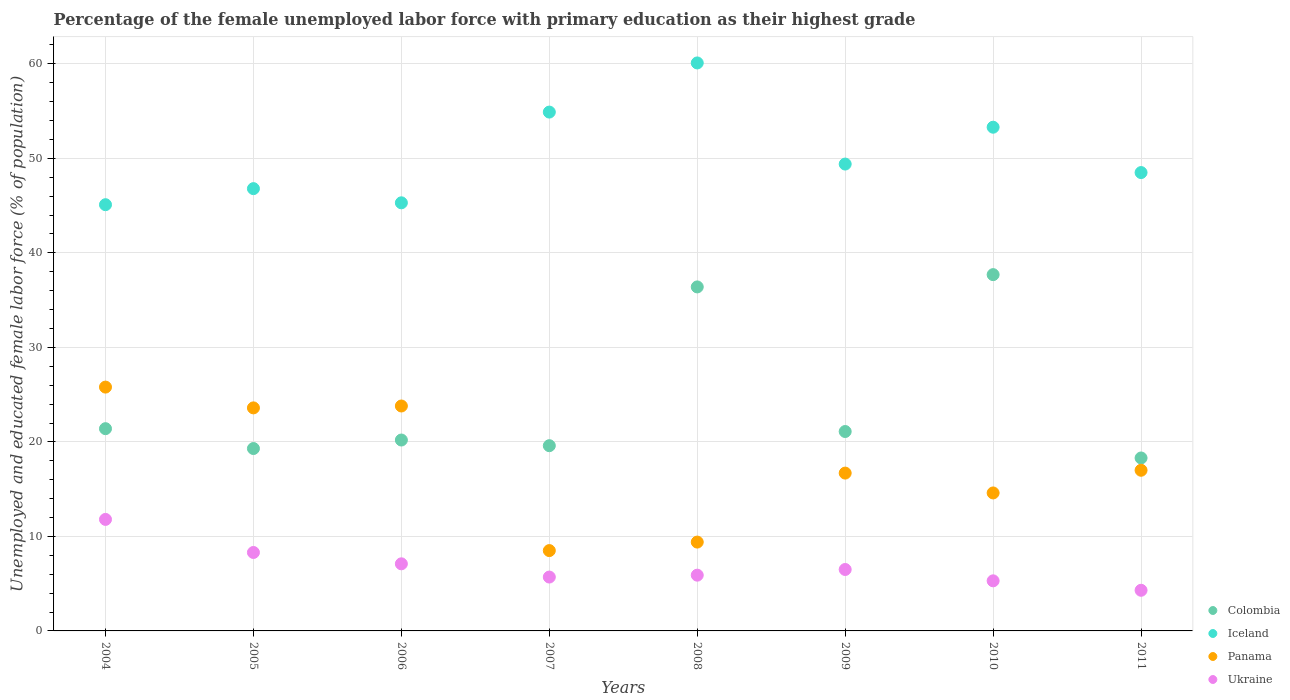How many different coloured dotlines are there?
Give a very brief answer. 4. Is the number of dotlines equal to the number of legend labels?
Provide a succinct answer. Yes. What is the percentage of the unemployed female labor force with primary education in Iceland in 2004?
Offer a very short reply. 45.1. Across all years, what is the maximum percentage of the unemployed female labor force with primary education in Iceland?
Offer a very short reply. 60.1. Across all years, what is the minimum percentage of the unemployed female labor force with primary education in Iceland?
Provide a short and direct response. 45.1. In which year was the percentage of the unemployed female labor force with primary education in Panama maximum?
Provide a succinct answer. 2004. What is the total percentage of the unemployed female labor force with primary education in Iceland in the graph?
Provide a short and direct response. 403.4. What is the difference between the percentage of the unemployed female labor force with primary education in Ukraine in 2004 and that in 2006?
Provide a short and direct response. 4.7. What is the difference between the percentage of the unemployed female labor force with primary education in Iceland in 2007 and the percentage of the unemployed female labor force with primary education in Panama in 2008?
Provide a short and direct response. 45.5. What is the average percentage of the unemployed female labor force with primary education in Ukraine per year?
Your answer should be very brief. 6.86. In the year 2009, what is the difference between the percentage of the unemployed female labor force with primary education in Colombia and percentage of the unemployed female labor force with primary education in Iceland?
Ensure brevity in your answer.  -28.3. In how many years, is the percentage of the unemployed female labor force with primary education in Iceland greater than 4 %?
Your response must be concise. 8. What is the ratio of the percentage of the unemployed female labor force with primary education in Colombia in 2010 to that in 2011?
Offer a very short reply. 2.06. Is the percentage of the unemployed female labor force with primary education in Colombia in 2004 less than that in 2010?
Your answer should be very brief. Yes. Is the difference between the percentage of the unemployed female labor force with primary education in Colombia in 2007 and 2009 greater than the difference between the percentage of the unemployed female labor force with primary education in Iceland in 2007 and 2009?
Your answer should be very brief. No. What is the difference between the highest and the second highest percentage of the unemployed female labor force with primary education in Iceland?
Your answer should be compact. 5.2. What is the difference between the highest and the lowest percentage of the unemployed female labor force with primary education in Colombia?
Ensure brevity in your answer.  19.4. In how many years, is the percentage of the unemployed female labor force with primary education in Colombia greater than the average percentage of the unemployed female labor force with primary education in Colombia taken over all years?
Ensure brevity in your answer.  2. Is the sum of the percentage of the unemployed female labor force with primary education in Ukraine in 2006 and 2007 greater than the maximum percentage of the unemployed female labor force with primary education in Colombia across all years?
Your answer should be very brief. No. Is the percentage of the unemployed female labor force with primary education in Colombia strictly less than the percentage of the unemployed female labor force with primary education in Panama over the years?
Keep it short and to the point. No. What is the difference between two consecutive major ticks on the Y-axis?
Offer a very short reply. 10. Are the values on the major ticks of Y-axis written in scientific E-notation?
Provide a succinct answer. No. Does the graph contain any zero values?
Make the answer very short. No. How many legend labels are there?
Ensure brevity in your answer.  4. What is the title of the graph?
Offer a terse response. Percentage of the female unemployed labor force with primary education as their highest grade. What is the label or title of the Y-axis?
Provide a short and direct response. Unemployed and educated female labor force (% of population). What is the Unemployed and educated female labor force (% of population) in Colombia in 2004?
Keep it short and to the point. 21.4. What is the Unemployed and educated female labor force (% of population) of Iceland in 2004?
Your response must be concise. 45.1. What is the Unemployed and educated female labor force (% of population) of Panama in 2004?
Ensure brevity in your answer.  25.8. What is the Unemployed and educated female labor force (% of population) of Ukraine in 2004?
Your answer should be compact. 11.8. What is the Unemployed and educated female labor force (% of population) of Colombia in 2005?
Provide a short and direct response. 19.3. What is the Unemployed and educated female labor force (% of population) in Iceland in 2005?
Offer a very short reply. 46.8. What is the Unemployed and educated female labor force (% of population) of Panama in 2005?
Give a very brief answer. 23.6. What is the Unemployed and educated female labor force (% of population) of Ukraine in 2005?
Keep it short and to the point. 8.3. What is the Unemployed and educated female labor force (% of population) in Colombia in 2006?
Give a very brief answer. 20.2. What is the Unemployed and educated female labor force (% of population) of Iceland in 2006?
Your response must be concise. 45.3. What is the Unemployed and educated female labor force (% of population) of Panama in 2006?
Make the answer very short. 23.8. What is the Unemployed and educated female labor force (% of population) of Ukraine in 2006?
Provide a short and direct response. 7.1. What is the Unemployed and educated female labor force (% of population) of Colombia in 2007?
Ensure brevity in your answer.  19.6. What is the Unemployed and educated female labor force (% of population) in Iceland in 2007?
Provide a succinct answer. 54.9. What is the Unemployed and educated female labor force (% of population) of Ukraine in 2007?
Provide a short and direct response. 5.7. What is the Unemployed and educated female labor force (% of population) in Colombia in 2008?
Ensure brevity in your answer.  36.4. What is the Unemployed and educated female labor force (% of population) of Iceland in 2008?
Offer a very short reply. 60.1. What is the Unemployed and educated female labor force (% of population) in Panama in 2008?
Offer a terse response. 9.4. What is the Unemployed and educated female labor force (% of population) in Ukraine in 2008?
Provide a succinct answer. 5.9. What is the Unemployed and educated female labor force (% of population) of Colombia in 2009?
Ensure brevity in your answer.  21.1. What is the Unemployed and educated female labor force (% of population) of Iceland in 2009?
Your answer should be compact. 49.4. What is the Unemployed and educated female labor force (% of population) in Panama in 2009?
Make the answer very short. 16.7. What is the Unemployed and educated female labor force (% of population) of Colombia in 2010?
Your answer should be very brief. 37.7. What is the Unemployed and educated female labor force (% of population) in Iceland in 2010?
Make the answer very short. 53.3. What is the Unemployed and educated female labor force (% of population) in Panama in 2010?
Your response must be concise. 14.6. What is the Unemployed and educated female labor force (% of population) in Ukraine in 2010?
Provide a short and direct response. 5.3. What is the Unemployed and educated female labor force (% of population) in Colombia in 2011?
Keep it short and to the point. 18.3. What is the Unemployed and educated female labor force (% of population) in Iceland in 2011?
Offer a terse response. 48.5. What is the Unemployed and educated female labor force (% of population) in Ukraine in 2011?
Provide a succinct answer. 4.3. Across all years, what is the maximum Unemployed and educated female labor force (% of population) in Colombia?
Your response must be concise. 37.7. Across all years, what is the maximum Unemployed and educated female labor force (% of population) of Iceland?
Give a very brief answer. 60.1. Across all years, what is the maximum Unemployed and educated female labor force (% of population) in Panama?
Give a very brief answer. 25.8. Across all years, what is the maximum Unemployed and educated female labor force (% of population) of Ukraine?
Your answer should be compact. 11.8. Across all years, what is the minimum Unemployed and educated female labor force (% of population) of Colombia?
Provide a succinct answer. 18.3. Across all years, what is the minimum Unemployed and educated female labor force (% of population) in Iceland?
Keep it short and to the point. 45.1. Across all years, what is the minimum Unemployed and educated female labor force (% of population) of Panama?
Make the answer very short. 8.5. Across all years, what is the minimum Unemployed and educated female labor force (% of population) of Ukraine?
Make the answer very short. 4.3. What is the total Unemployed and educated female labor force (% of population) of Colombia in the graph?
Your answer should be compact. 194. What is the total Unemployed and educated female labor force (% of population) in Iceland in the graph?
Your answer should be very brief. 403.4. What is the total Unemployed and educated female labor force (% of population) of Panama in the graph?
Your answer should be compact. 139.4. What is the total Unemployed and educated female labor force (% of population) in Ukraine in the graph?
Give a very brief answer. 54.9. What is the difference between the Unemployed and educated female labor force (% of population) of Colombia in 2004 and that in 2005?
Ensure brevity in your answer.  2.1. What is the difference between the Unemployed and educated female labor force (% of population) in Iceland in 2004 and that in 2005?
Provide a short and direct response. -1.7. What is the difference between the Unemployed and educated female labor force (% of population) of Ukraine in 2004 and that in 2005?
Make the answer very short. 3.5. What is the difference between the Unemployed and educated female labor force (% of population) in Colombia in 2004 and that in 2006?
Your answer should be very brief. 1.2. What is the difference between the Unemployed and educated female labor force (% of population) of Iceland in 2004 and that in 2006?
Give a very brief answer. -0.2. What is the difference between the Unemployed and educated female labor force (% of population) of Ukraine in 2004 and that in 2006?
Keep it short and to the point. 4.7. What is the difference between the Unemployed and educated female labor force (% of population) of Panama in 2004 and that in 2007?
Ensure brevity in your answer.  17.3. What is the difference between the Unemployed and educated female labor force (% of population) in Iceland in 2004 and that in 2008?
Offer a terse response. -15. What is the difference between the Unemployed and educated female labor force (% of population) in Panama in 2004 and that in 2008?
Make the answer very short. 16.4. What is the difference between the Unemployed and educated female labor force (% of population) of Colombia in 2004 and that in 2009?
Make the answer very short. 0.3. What is the difference between the Unemployed and educated female labor force (% of population) in Iceland in 2004 and that in 2009?
Your answer should be very brief. -4.3. What is the difference between the Unemployed and educated female labor force (% of population) of Panama in 2004 and that in 2009?
Your response must be concise. 9.1. What is the difference between the Unemployed and educated female labor force (% of population) of Colombia in 2004 and that in 2010?
Offer a terse response. -16.3. What is the difference between the Unemployed and educated female labor force (% of population) in Iceland in 2004 and that in 2010?
Your response must be concise. -8.2. What is the difference between the Unemployed and educated female labor force (% of population) of Iceland in 2004 and that in 2011?
Offer a terse response. -3.4. What is the difference between the Unemployed and educated female labor force (% of population) of Colombia in 2005 and that in 2006?
Your answer should be very brief. -0.9. What is the difference between the Unemployed and educated female labor force (% of population) of Iceland in 2005 and that in 2006?
Provide a succinct answer. 1.5. What is the difference between the Unemployed and educated female labor force (% of population) of Ukraine in 2005 and that in 2006?
Keep it short and to the point. 1.2. What is the difference between the Unemployed and educated female labor force (% of population) of Panama in 2005 and that in 2007?
Provide a succinct answer. 15.1. What is the difference between the Unemployed and educated female labor force (% of population) in Colombia in 2005 and that in 2008?
Your answer should be very brief. -17.1. What is the difference between the Unemployed and educated female labor force (% of population) of Iceland in 2005 and that in 2009?
Make the answer very short. -2.6. What is the difference between the Unemployed and educated female labor force (% of population) of Ukraine in 2005 and that in 2009?
Your response must be concise. 1.8. What is the difference between the Unemployed and educated female labor force (% of population) in Colombia in 2005 and that in 2010?
Ensure brevity in your answer.  -18.4. What is the difference between the Unemployed and educated female labor force (% of population) in Iceland in 2005 and that in 2010?
Give a very brief answer. -6.5. What is the difference between the Unemployed and educated female labor force (% of population) in Panama in 2005 and that in 2010?
Keep it short and to the point. 9. What is the difference between the Unemployed and educated female labor force (% of population) of Ukraine in 2005 and that in 2011?
Your response must be concise. 4. What is the difference between the Unemployed and educated female labor force (% of population) of Iceland in 2006 and that in 2007?
Your answer should be compact. -9.6. What is the difference between the Unemployed and educated female labor force (% of population) in Panama in 2006 and that in 2007?
Provide a short and direct response. 15.3. What is the difference between the Unemployed and educated female labor force (% of population) of Colombia in 2006 and that in 2008?
Offer a very short reply. -16.2. What is the difference between the Unemployed and educated female labor force (% of population) of Iceland in 2006 and that in 2008?
Provide a succinct answer. -14.8. What is the difference between the Unemployed and educated female labor force (% of population) in Panama in 2006 and that in 2008?
Offer a terse response. 14.4. What is the difference between the Unemployed and educated female labor force (% of population) in Colombia in 2006 and that in 2009?
Offer a terse response. -0.9. What is the difference between the Unemployed and educated female labor force (% of population) in Iceland in 2006 and that in 2009?
Your answer should be compact. -4.1. What is the difference between the Unemployed and educated female labor force (% of population) of Panama in 2006 and that in 2009?
Your answer should be compact. 7.1. What is the difference between the Unemployed and educated female labor force (% of population) of Ukraine in 2006 and that in 2009?
Provide a succinct answer. 0.6. What is the difference between the Unemployed and educated female labor force (% of population) in Colombia in 2006 and that in 2010?
Provide a succinct answer. -17.5. What is the difference between the Unemployed and educated female labor force (% of population) of Panama in 2006 and that in 2010?
Your answer should be very brief. 9.2. What is the difference between the Unemployed and educated female labor force (% of population) of Colombia in 2007 and that in 2008?
Your response must be concise. -16.8. What is the difference between the Unemployed and educated female labor force (% of population) in Iceland in 2007 and that in 2008?
Make the answer very short. -5.2. What is the difference between the Unemployed and educated female labor force (% of population) in Panama in 2007 and that in 2008?
Offer a terse response. -0.9. What is the difference between the Unemployed and educated female labor force (% of population) in Iceland in 2007 and that in 2009?
Your answer should be compact. 5.5. What is the difference between the Unemployed and educated female labor force (% of population) of Ukraine in 2007 and that in 2009?
Provide a short and direct response. -0.8. What is the difference between the Unemployed and educated female labor force (% of population) in Colombia in 2007 and that in 2010?
Ensure brevity in your answer.  -18.1. What is the difference between the Unemployed and educated female labor force (% of population) in Panama in 2007 and that in 2010?
Give a very brief answer. -6.1. What is the difference between the Unemployed and educated female labor force (% of population) of Colombia in 2008 and that in 2009?
Provide a short and direct response. 15.3. What is the difference between the Unemployed and educated female labor force (% of population) in Panama in 2008 and that in 2009?
Provide a short and direct response. -7.3. What is the difference between the Unemployed and educated female labor force (% of population) of Panama in 2008 and that in 2010?
Your answer should be compact. -5.2. What is the difference between the Unemployed and educated female labor force (% of population) in Colombia in 2009 and that in 2010?
Your answer should be compact. -16.6. What is the difference between the Unemployed and educated female labor force (% of population) in Colombia in 2009 and that in 2011?
Make the answer very short. 2.8. What is the difference between the Unemployed and educated female labor force (% of population) in Iceland in 2009 and that in 2011?
Your answer should be very brief. 0.9. What is the difference between the Unemployed and educated female labor force (% of population) of Iceland in 2010 and that in 2011?
Offer a terse response. 4.8. What is the difference between the Unemployed and educated female labor force (% of population) in Panama in 2010 and that in 2011?
Keep it short and to the point. -2.4. What is the difference between the Unemployed and educated female labor force (% of population) in Ukraine in 2010 and that in 2011?
Offer a very short reply. 1. What is the difference between the Unemployed and educated female labor force (% of population) in Colombia in 2004 and the Unemployed and educated female labor force (% of population) in Iceland in 2005?
Make the answer very short. -25.4. What is the difference between the Unemployed and educated female labor force (% of population) of Iceland in 2004 and the Unemployed and educated female labor force (% of population) of Panama in 2005?
Your response must be concise. 21.5. What is the difference between the Unemployed and educated female labor force (% of population) in Iceland in 2004 and the Unemployed and educated female labor force (% of population) in Ukraine in 2005?
Your response must be concise. 36.8. What is the difference between the Unemployed and educated female labor force (% of population) of Panama in 2004 and the Unemployed and educated female labor force (% of population) of Ukraine in 2005?
Offer a terse response. 17.5. What is the difference between the Unemployed and educated female labor force (% of population) in Colombia in 2004 and the Unemployed and educated female labor force (% of population) in Iceland in 2006?
Your answer should be compact. -23.9. What is the difference between the Unemployed and educated female labor force (% of population) of Colombia in 2004 and the Unemployed and educated female labor force (% of population) of Panama in 2006?
Your answer should be compact. -2.4. What is the difference between the Unemployed and educated female labor force (% of population) of Iceland in 2004 and the Unemployed and educated female labor force (% of population) of Panama in 2006?
Keep it short and to the point. 21.3. What is the difference between the Unemployed and educated female labor force (% of population) of Colombia in 2004 and the Unemployed and educated female labor force (% of population) of Iceland in 2007?
Give a very brief answer. -33.5. What is the difference between the Unemployed and educated female labor force (% of population) of Colombia in 2004 and the Unemployed and educated female labor force (% of population) of Panama in 2007?
Give a very brief answer. 12.9. What is the difference between the Unemployed and educated female labor force (% of population) in Iceland in 2004 and the Unemployed and educated female labor force (% of population) in Panama in 2007?
Provide a short and direct response. 36.6. What is the difference between the Unemployed and educated female labor force (% of population) of Iceland in 2004 and the Unemployed and educated female labor force (% of population) of Ukraine in 2007?
Your answer should be compact. 39.4. What is the difference between the Unemployed and educated female labor force (% of population) of Panama in 2004 and the Unemployed and educated female labor force (% of population) of Ukraine in 2007?
Keep it short and to the point. 20.1. What is the difference between the Unemployed and educated female labor force (% of population) of Colombia in 2004 and the Unemployed and educated female labor force (% of population) of Iceland in 2008?
Ensure brevity in your answer.  -38.7. What is the difference between the Unemployed and educated female labor force (% of population) of Iceland in 2004 and the Unemployed and educated female labor force (% of population) of Panama in 2008?
Your answer should be very brief. 35.7. What is the difference between the Unemployed and educated female labor force (% of population) of Iceland in 2004 and the Unemployed and educated female labor force (% of population) of Ukraine in 2008?
Provide a succinct answer. 39.2. What is the difference between the Unemployed and educated female labor force (% of population) in Panama in 2004 and the Unemployed and educated female labor force (% of population) in Ukraine in 2008?
Give a very brief answer. 19.9. What is the difference between the Unemployed and educated female labor force (% of population) of Colombia in 2004 and the Unemployed and educated female labor force (% of population) of Ukraine in 2009?
Your response must be concise. 14.9. What is the difference between the Unemployed and educated female labor force (% of population) of Iceland in 2004 and the Unemployed and educated female labor force (% of population) of Panama in 2009?
Offer a terse response. 28.4. What is the difference between the Unemployed and educated female labor force (% of population) of Iceland in 2004 and the Unemployed and educated female labor force (% of population) of Ukraine in 2009?
Your response must be concise. 38.6. What is the difference between the Unemployed and educated female labor force (% of population) of Panama in 2004 and the Unemployed and educated female labor force (% of population) of Ukraine in 2009?
Provide a succinct answer. 19.3. What is the difference between the Unemployed and educated female labor force (% of population) in Colombia in 2004 and the Unemployed and educated female labor force (% of population) in Iceland in 2010?
Offer a very short reply. -31.9. What is the difference between the Unemployed and educated female labor force (% of population) in Colombia in 2004 and the Unemployed and educated female labor force (% of population) in Panama in 2010?
Ensure brevity in your answer.  6.8. What is the difference between the Unemployed and educated female labor force (% of population) of Colombia in 2004 and the Unemployed and educated female labor force (% of population) of Ukraine in 2010?
Provide a succinct answer. 16.1. What is the difference between the Unemployed and educated female labor force (% of population) of Iceland in 2004 and the Unemployed and educated female labor force (% of population) of Panama in 2010?
Keep it short and to the point. 30.5. What is the difference between the Unemployed and educated female labor force (% of population) in Iceland in 2004 and the Unemployed and educated female labor force (% of population) in Ukraine in 2010?
Offer a terse response. 39.8. What is the difference between the Unemployed and educated female labor force (% of population) in Colombia in 2004 and the Unemployed and educated female labor force (% of population) in Iceland in 2011?
Your answer should be very brief. -27.1. What is the difference between the Unemployed and educated female labor force (% of population) in Colombia in 2004 and the Unemployed and educated female labor force (% of population) in Panama in 2011?
Your answer should be very brief. 4.4. What is the difference between the Unemployed and educated female labor force (% of population) of Iceland in 2004 and the Unemployed and educated female labor force (% of population) of Panama in 2011?
Your answer should be compact. 28.1. What is the difference between the Unemployed and educated female labor force (% of population) in Iceland in 2004 and the Unemployed and educated female labor force (% of population) in Ukraine in 2011?
Your answer should be very brief. 40.8. What is the difference between the Unemployed and educated female labor force (% of population) of Colombia in 2005 and the Unemployed and educated female labor force (% of population) of Panama in 2006?
Your response must be concise. -4.5. What is the difference between the Unemployed and educated female labor force (% of population) of Iceland in 2005 and the Unemployed and educated female labor force (% of population) of Panama in 2006?
Provide a short and direct response. 23. What is the difference between the Unemployed and educated female labor force (% of population) in Iceland in 2005 and the Unemployed and educated female labor force (% of population) in Ukraine in 2006?
Your response must be concise. 39.7. What is the difference between the Unemployed and educated female labor force (% of population) of Panama in 2005 and the Unemployed and educated female labor force (% of population) of Ukraine in 2006?
Your answer should be compact. 16.5. What is the difference between the Unemployed and educated female labor force (% of population) in Colombia in 2005 and the Unemployed and educated female labor force (% of population) in Iceland in 2007?
Keep it short and to the point. -35.6. What is the difference between the Unemployed and educated female labor force (% of population) in Colombia in 2005 and the Unemployed and educated female labor force (% of population) in Panama in 2007?
Provide a short and direct response. 10.8. What is the difference between the Unemployed and educated female labor force (% of population) of Iceland in 2005 and the Unemployed and educated female labor force (% of population) of Panama in 2007?
Your answer should be very brief. 38.3. What is the difference between the Unemployed and educated female labor force (% of population) of Iceland in 2005 and the Unemployed and educated female labor force (% of population) of Ukraine in 2007?
Give a very brief answer. 41.1. What is the difference between the Unemployed and educated female labor force (% of population) in Panama in 2005 and the Unemployed and educated female labor force (% of population) in Ukraine in 2007?
Your response must be concise. 17.9. What is the difference between the Unemployed and educated female labor force (% of population) of Colombia in 2005 and the Unemployed and educated female labor force (% of population) of Iceland in 2008?
Offer a terse response. -40.8. What is the difference between the Unemployed and educated female labor force (% of population) of Colombia in 2005 and the Unemployed and educated female labor force (% of population) of Panama in 2008?
Ensure brevity in your answer.  9.9. What is the difference between the Unemployed and educated female labor force (% of population) of Colombia in 2005 and the Unemployed and educated female labor force (% of population) of Ukraine in 2008?
Provide a succinct answer. 13.4. What is the difference between the Unemployed and educated female labor force (% of population) in Iceland in 2005 and the Unemployed and educated female labor force (% of population) in Panama in 2008?
Provide a succinct answer. 37.4. What is the difference between the Unemployed and educated female labor force (% of population) in Iceland in 2005 and the Unemployed and educated female labor force (% of population) in Ukraine in 2008?
Offer a very short reply. 40.9. What is the difference between the Unemployed and educated female labor force (% of population) in Panama in 2005 and the Unemployed and educated female labor force (% of population) in Ukraine in 2008?
Offer a terse response. 17.7. What is the difference between the Unemployed and educated female labor force (% of population) in Colombia in 2005 and the Unemployed and educated female labor force (% of population) in Iceland in 2009?
Ensure brevity in your answer.  -30.1. What is the difference between the Unemployed and educated female labor force (% of population) in Colombia in 2005 and the Unemployed and educated female labor force (% of population) in Ukraine in 2009?
Give a very brief answer. 12.8. What is the difference between the Unemployed and educated female labor force (% of population) in Iceland in 2005 and the Unemployed and educated female labor force (% of population) in Panama in 2009?
Offer a very short reply. 30.1. What is the difference between the Unemployed and educated female labor force (% of population) in Iceland in 2005 and the Unemployed and educated female labor force (% of population) in Ukraine in 2009?
Your response must be concise. 40.3. What is the difference between the Unemployed and educated female labor force (% of population) of Colombia in 2005 and the Unemployed and educated female labor force (% of population) of Iceland in 2010?
Make the answer very short. -34. What is the difference between the Unemployed and educated female labor force (% of population) of Colombia in 2005 and the Unemployed and educated female labor force (% of population) of Ukraine in 2010?
Your answer should be compact. 14. What is the difference between the Unemployed and educated female labor force (% of population) of Iceland in 2005 and the Unemployed and educated female labor force (% of population) of Panama in 2010?
Keep it short and to the point. 32.2. What is the difference between the Unemployed and educated female labor force (% of population) in Iceland in 2005 and the Unemployed and educated female labor force (% of population) in Ukraine in 2010?
Offer a terse response. 41.5. What is the difference between the Unemployed and educated female labor force (% of population) of Colombia in 2005 and the Unemployed and educated female labor force (% of population) of Iceland in 2011?
Make the answer very short. -29.2. What is the difference between the Unemployed and educated female labor force (% of population) of Colombia in 2005 and the Unemployed and educated female labor force (% of population) of Ukraine in 2011?
Make the answer very short. 15. What is the difference between the Unemployed and educated female labor force (% of population) of Iceland in 2005 and the Unemployed and educated female labor force (% of population) of Panama in 2011?
Give a very brief answer. 29.8. What is the difference between the Unemployed and educated female labor force (% of population) of Iceland in 2005 and the Unemployed and educated female labor force (% of population) of Ukraine in 2011?
Offer a very short reply. 42.5. What is the difference between the Unemployed and educated female labor force (% of population) in Panama in 2005 and the Unemployed and educated female labor force (% of population) in Ukraine in 2011?
Offer a terse response. 19.3. What is the difference between the Unemployed and educated female labor force (% of population) of Colombia in 2006 and the Unemployed and educated female labor force (% of population) of Iceland in 2007?
Your answer should be compact. -34.7. What is the difference between the Unemployed and educated female labor force (% of population) of Colombia in 2006 and the Unemployed and educated female labor force (% of population) of Ukraine in 2007?
Make the answer very short. 14.5. What is the difference between the Unemployed and educated female labor force (% of population) in Iceland in 2006 and the Unemployed and educated female labor force (% of population) in Panama in 2007?
Your answer should be compact. 36.8. What is the difference between the Unemployed and educated female labor force (% of population) in Iceland in 2006 and the Unemployed and educated female labor force (% of population) in Ukraine in 2007?
Give a very brief answer. 39.6. What is the difference between the Unemployed and educated female labor force (% of population) of Colombia in 2006 and the Unemployed and educated female labor force (% of population) of Iceland in 2008?
Provide a succinct answer. -39.9. What is the difference between the Unemployed and educated female labor force (% of population) of Colombia in 2006 and the Unemployed and educated female labor force (% of population) of Ukraine in 2008?
Your answer should be compact. 14.3. What is the difference between the Unemployed and educated female labor force (% of population) in Iceland in 2006 and the Unemployed and educated female labor force (% of population) in Panama in 2008?
Offer a very short reply. 35.9. What is the difference between the Unemployed and educated female labor force (% of population) in Iceland in 2006 and the Unemployed and educated female labor force (% of population) in Ukraine in 2008?
Provide a short and direct response. 39.4. What is the difference between the Unemployed and educated female labor force (% of population) of Panama in 2006 and the Unemployed and educated female labor force (% of population) of Ukraine in 2008?
Provide a short and direct response. 17.9. What is the difference between the Unemployed and educated female labor force (% of population) in Colombia in 2006 and the Unemployed and educated female labor force (% of population) in Iceland in 2009?
Offer a terse response. -29.2. What is the difference between the Unemployed and educated female labor force (% of population) in Colombia in 2006 and the Unemployed and educated female labor force (% of population) in Ukraine in 2009?
Your answer should be very brief. 13.7. What is the difference between the Unemployed and educated female labor force (% of population) of Iceland in 2006 and the Unemployed and educated female labor force (% of population) of Panama in 2009?
Offer a terse response. 28.6. What is the difference between the Unemployed and educated female labor force (% of population) in Iceland in 2006 and the Unemployed and educated female labor force (% of population) in Ukraine in 2009?
Provide a short and direct response. 38.8. What is the difference between the Unemployed and educated female labor force (% of population) in Colombia in 2006 and the Unemployed and educated female labor force (% of population) in Iceland in 2010?
Your answer should be very brief. -33.1. What is the difference between the Unemployed and educated female labor force (% of population) of Colombia in 2006 and the Unemployed and educated female labor force (% of population) of Panama in 2010?
Provide a short and direct response. 5.6. What is the difference between the Unemployed and educated female labor force (% of population) of Colombia in 2006 and the Unemployed and educated female labor force (% of population) of Ukraine in 2010?
Keep it short and to the point. 14.9. What is the difference between the Unemployed and educated female labor force (% of population) of Iceland in 2006 and the Unemployed and educated female labor force (% of population) of Panama in 2010?
Provide a succinct answer. 30.7. What is the difference between the Unemployed and educated female labor force (% of population) in Panama in 2006 and the Unemployed and educated female labor force (% of population) in Ukraine in 2010?
Offer a very short reply. 18.5. What is the difference between the Unemployed and educated female labor force (% of population) of Colombia in 2006 and the Unemployed and educated female labor force (% of population) of Iceland in 2011?
Make the answer very short. -28.3. What is the difference between the Unemployed and educated female labor force (% of population) in Colombia in 2006 and the Unemployed and educated female labor force (% of population) in Panama in 2011?
Ensure brevity in your answer.  3.2. What is the difference between the Unemployed and educated female labor force (% of population) of Colombia in 2006 and the Unemployed and educated female labor force (% of population) of Ukraine in 2011?
Your response must be concise. 15.9. What is the difference between the Unemployed and educated female labor force (% of population) in Iceland in 2006 and the Unemployed and educated female labor force (% of population) in Panama in 2011?
Offer a very short reply. 28.3. What is the difference between the Unemployed and educated female labor force (% of population) of Iceland in 2006 and the Unemployed and educated female labor force (% of population) of Ukraine in 2011?
Provide a short and direct response. 41. What is the difference between the Unemployed and educated female labor force (% of population) of Colombia in 2007 and the Unemployed and educated female labor force (% of population) of Iceland in 2008?
Provide a short and direct response. -40.5. What is the difference between the Unemployed and educated female labor force (% of population) of Iceland in 2007 and the Unemployed and educated female labor force (% of population) of Panama in 2008?
Offer a very short reply. 45.5. What is the difference between the Unemployed and educated female labor force (% of population) in Iceland in 2007 and the Unemployed and educated female labor force (% of population) in Ukraine in 2008?
Provide a succinct answer. 49. What is the difference between the Unemployed and educated female labor force (% of population) of Panama in 2007 and the Unemployed and educated female labor force (% of population) of Ukraine in 2008?
Provide a short and direct response. 2.6. What is the difference between the Unemployed and educated female labor force (% of population) in Colombia in 2007 and the Unemployed and educated female labor force (% of population) in Iceland in 2009?
Offer a very short reply. -29.8. What is the difference between the Unemployed and educated female labor force (% of population) of Colombia in 2007 and the Unemployed and educated female labor force (% of population) of Panama in 2009?
Provide a succinct answer. 2.9. What is the difference between the Unemployed and educated female labor force (% of population) in Iceland in 2007 and the Unemployed and educated female labor force (% of population) in Panama in 2009?
Provide a short and direct response. 38.2. What is the difference between the Unemployed and educated female labor force (% of population) of Iceland in 2007 and the Unemployed and educated female labor force (% of population) of Ukraine in 2009?
Your answer should be very brief. 48.4. What is the difference between the Unemployed and educated female labor force (% of population) in Colombia in 2007 and the Unemployed and educated female labor force (% of population) in Iceland in 2010?
Offer a very short reply. -33.7. What is the difference between the Unemployed and educated female labor force (% of population) in Colombia in 2007 and the Unemployed and educated female labor force (% of population) in Panama in 2010?
Keep it short and to the point. 5. What is the difference between the Unemployed and educated female labor force (% of population) in Iceland in 2007 and the Unemployed and educated female labor force (% of population) in Panama in 2010?
Provide a short and direct response. 40.3. What is the difference between the Unemployed and educated female labor force (% of population) in Iceland in 2007 and the Unemployed and educated female labor force (% of population) in Ukraine in 2010?
Your answer should be very brief. 49.6. What is the difference between the Unemployed and educated female labor force (% of population) of Panama in 2007 and the Unemployed and educated female labor force (% of population) of Ukraine in 2010?
Your answer should be compact. 3.2. What is the difference between the Unemployed and educated female labor force (% of population) of Colombia in 2007 and the Unemployed and educated female labor force (% of population) of Iceland in 2011?
Provide a short and direct response. -28.9. What is the difference between the Unemployed and educated female labor force (% of population) in Colombia in 2007 and the Unemployed and educated female labor force (% of population) in Panama in 2011?
Provide a short and direct response. 2.6. What is the difference between the Unemployed and educated female labor force (% of population) of Iceland in 2007 and the Unemployed and educated female labor force (% of population) of Panama in 2011?
Keep it short and to the point. 37.9. What is the difference between the Unemployed and educated female labor force (% of population) in Iceland in 2007 and the Unemployed and educated female labor force (% of population) in Ukraine in 2011?
Make the answer very short. 50.6. What is the difference between the Unemployed and educated female labor force (% of population) of Panama in 2007 and the Unemployed and educated female labor force (% of population) of Ukraine in 2011?
Offer a very short reply. 4.2. What is the difference between the Unemployed and educated female labor force (% of population) of Colombia in 2008 and the Unemployed and educated female labor force (% of population) of Iceland in 2009?
Your answer should be very brief. -13. What is the difference between the Unemployed and educated female labor force (% of population) in Colombia in 2008 and the Unemployed and educated female labor force (% of population) in Ukraine in 2009?
Offer a very short reply. 29.9. What is the difference between the Unemployed and educated female labor force (% of population) of Iceland in 2008 and the Unemployed and educated female labor force (% of population) of Panama in 2009?
Offer a very short reply. 43.4. What is the difference between the Unemployed and educated female labor force (% of population) in Iceland in 2008 and the Unemployed and educated female labor force (% of population) in Ukraine in 2009?
Provide a short and direct response. 53.6. What is the difference between the Unemployed and educated female labor force (% of population) of Panama in 2008 and the Unemployed and educated female labor force (% of population) of Ukraine in 2009?
Make the answer very short. 2.9. What is the difference between the Unemployed and educated female labor force (% of population) of Colombia in 2008 and the Unemployed and educated female labor force (% of population) of Iceland in 2010?
Offer a terse response. -16.9. What is the difference between the Unemployed and educated female labor force (% of population) of Colombia in 2008 and the Unemployed and educated female labor force (% of population) of Panama in 2010?
Your response must be concise. 21.8. What is the difference between the Unemployed and educated female labor force (% of population) in Colombia in 2008 and the Unemployed and educated female labor force (% of population) in Ukraine in 2010?
Offer a very short reply. 31.1. What is the difference between the Unemployed and educated female labor force (% of population) of Iceland in 2008 and the Unemployed and educated female labor force (% of population) of Panama in 2010?
Your answer should be compact. 45.5. What is the difference between the Unemployed and educated female labor force (% of population) in Iceland in 2008 and the Unemployed and educated female labor force (% of population) in Ukraine in 2010?
Your answer should be compact. 54.8. What is the difference between the Unemployed and educated female labor force (% of population) of Colombia in 2008 and the Unemployed and educated female labor force (% of population) of Iceland in 2011?
Provide a succinct answer. -12.1. What is the difference between the Unemployed and educated female labor force (% of population) in Colombia in 2008 and the Unemployed and educated female labor force (% of population) in Panama in 2011?
Offer a terse response. 19.4. What is the difference between the Unemployed and educated female labor force (% of population) of Colombia in 2008 and the Unemployed and educated female labor force (% of population) of Ukraine in 2011?
Provide a short and direct response. 32.1. What is the difference between the Unemployed and educated female labor force (% of population) of Iceland in 2008 and the Unemployed and educated female labor force (% of population) of Panama in 2011?
Provide a succinct answer. 43.1. What is the difference between the Unemployed and educated female labor force (% of population) in Iceland in 2008 and the Unemployed and educated female labor force (% of population) in Ukraine in 2011?
Your answer should be very brief. 55.8. What is the difference between the Unemployed and educated female labor force (% of population) in Colombia in 2009 and the Unemployed and educated female labor force (% of population) in Iceland in 2010?
Ensure brevity in your answer.  -32.2. What is the difference between the Unemployed and educated female labor force (% of population) in Colombia in 2009 and the Unemployed and educated female labor force (% of population) in Ukraine in 2010?
Provide a short and direct response. 15.8. What is the difference between the Unemployed and educated female labor force (% of population) of Iceland in 2009 and the Unemployed and educated female labor force (% of population) of Panama in 2010?
Give a very brief answer. 34.8. What is the difference between the Unemployed and educated female labor force (% of population) in Iceland in 2009 and the Unemployed and educated female labor force (% of population) in Ukraine in 2010?
Offer a very short reply. 44.1. What is the difference between the Unemployed and educated female labor force (% of population) in Colombia in 2009 and the Unemployed and educated female labor force (% of population) in Iceland in 2011?
Offer a terse response. -27.4. What is the difference between the Unemployed and educated female labor force (% of population) in Iceland in 2009 and the Unemployed and educated female labor force (% of population) in Panama in 2011?
Ensure brevity in your answer.  32.4. What is the difference between the Unemployed and educated female labor force (% of population) of Iceland in 2009 and the Unemployed and educated female labor force (% of population) of Ukraine in 2011?
Ensure brevity in your answer.  45.1. What is the difference between the Unemployed and educated female labor force (% of population) in Colombia in 2010 and the Unemployed and educated female labor force (% of population) in Iceland in 2011?
Provide a succinct answer. -10.8. What is the difference between the Unemployed and educated female labor force (% of population) of Colombia in 2010 and the Unemployed and educated female labor force (% of population) of Panama in 2011?
Provide a short and direct response. 20.7. What is the difference between the Unemployed and educated female labor force (% of population) in Colombia in 2010 and the Unemployed and educated female labor force (% of population) in Ukraine in 2011?
Keep it short and to the point. 33.4. What is the difference between the Unemployed and educated female labor force (% of population) of Iceland in 2010 and the Unemployed and educated female labor force (% of population) of Panama in 2011?
Your response must be concise. 36.3. What is the average Unemployed and educated female labor force (% of population) in Colombia per year?
Make the answer very short. 24.25. What is the average Unemployed and educated female labor force (% of population) in Iceland per year?
Your response must be concise. 50.42. What is the average Unemployed and educated female labor force (% of population) in Panama per year?
Offer a very short reply. 17.43. What is the average Unemployed and educated female labor force (% of population) in Ukraine per year?
Make the answer very short. 6.86. In the year 2004, what is the difference between the Unemployed and educated female labor force (% of population) in Colombia and Unemployed and educated female labor force (% of population) in Iceland?
Your answer should be very brief. -23.7. In the year 2004, what is the difference between the Unemployed and educated female labor force (% of population) of Colombia and Unemployed and educated female labor force (% of population) of Ukraine?
Keep it short and to the point. 9.6. In the year 2004, what is the difference between the Unemployed and educated female labor force (% of population) of Iceland and Unemployed and educated female labor force (% of population) of Panama?
Your response must be concise. 19.3. In the year 2004, what is the difference between the Unemployed and educated female labor force (% of population) in Iceland and Unemployed and educated female labor force (% of population) in Ukraine?
Provide a succinct answer. 33.3. In the year 2005, what is the difference between the Unemployed and educated female labor force (% of population) of Colombia and Unemployed and educated female labor force (% of population) of Iceland?
Give a very brief answer. -27.5. In the year 2005, what is the difference between the Unemployed and educated female labor force (% of population) of Colombia and Unemployed and educated female labor force (% of population) of Panama?
Give a very brief answer. -4.3. In the year 2005, what is the difference between the Unemployed and educated female labor force (% of population) in Colombia and Unemployed and educated female labor force (% of population) in Ukraine?
Offer a very short reply. 11. In the year 2005, what is the difference between the Unemployed and educated female labor force (% of population) in Iceland and Unemployed and educated female labor force (% of population) in Panama?
Your answer should be very brief. 23.2. In the year 2005, what is the difference between the Unemployed and educated female labor force (% of population) in Iceland and Unemployed and educated female labor force (% of population) in Ukraine?
Keep it short and to the point. 38.5. In the year 2005, what is the difference between the Unemployed and educated female labor force (% of population) of Panama and Unemployed and educated female labor force (% of population) of Ukraine?
Ensure brevity in your answer.  15.3. In the year 2006, what is the difference between the Unemployed and educated female labor force (% of population) in Colombia and Unemployed and educated female labor force (% of population) in Iceland?
Keep it short and to the point. -25.1. In the year 2006, what is the difference between the Unemployed and educated female labor force (% of population) of Iceland and Unemployed and educated female labor force (% of population) of Panama?
Provide a succinct answer. 21.5. In the year 2006, what is the difference between the Unemployed and educated female labor force (% of population) in Iceland and Unemployed and educated female labor force (% of population) in Ukraine?
Offer a very short reply. 38.2. In the year 2006, what is the difference between the Unemployed and educated female labor force (% of population) of Panama and Unemployed and educated female labor force (% of population) of Ukraine?
Offer a terse response. 16.7. In the year 2007, what is the difference between the Unemployed and educated female labor force (% of population) in Colombia and Unemployed and educated female labor force (% of population) in Iceland?
Provide a short and direct response. -35.3. In the year 2007, what is the difference between the Unemployed and educated female labor force (% of population) of Iceland and Unemployed and educated female labor force (% of population) of Panama?
Your answer should be very brief. 46.4. In the year 2007, what is the difference between the Unemployed and educated female labor force (% of population) in Iceland and Unemployed and educated female labor force (% of population) in Ukraine?
Give a very brief answer. 49.2. In the year 2007, what is the difference between the Unemployed and educated female labor force (% of population) of Panama and Unemployed and educated female labor force (% of population) of Ukraine?
Give a very brief answer. 2.8. In the year 2008, what is the difference between the Unemployed and educated female labor force (% of population) of Colombia and Unemployed and educated female labor force (% of population) of Iceland?
Give a very brief answer. -23.7. In the year 2008, what is the difference between the Unemployed and educated female labor force (% of population) in Colombia and Unemployed and educated female labor force (% of population) in Panama?
Your answer should be compact. 27. In the year 2008, what is the difference between the Unemployed and educated female labor force (% of population) of Colombia and Unemployed and educated female labor force (% of population) of Ukraine?
Ensure brevity in your answer.  30.5. In the year 2008, what is the difference between the Unemployed and educated female labor force (% of population) in Iceland and Unemployed and educated female labor force (% of population) in Panama?
Your answer should be compact. 50.7. In the year 2008, what is the difference between the Unemployed and educated female labor force (% of population) of Iceland and Unemployed and educated female labor force (% of population) of Ukraine?
Your response must be concise. 54.2. In the year 2008, what is the difference between the Unemployed and educated female labor force (% of population) in Panama and Unemployed and educated female labor force (% of population) in Ukraine?
Provide a succinct answer. 3.5. In the year 2009, what is the difference between the Unemployed and educated female labor force (% of population) in Colombia and Unemployed and educated female labor force (% of population) in Iceland?
Offer a very short reply. -28.3. In the year 2009, what is the difference between the Unemployed and educated female labor force (% of population) in Colombia and Unemployed and educated female labor force (% of population) in Panama?
Ensure brevity in your answer.  4.4. In the year 2009, what is the difference between the Unemployed and educated female labor force (% of population) in Colombia and Unemployed and educated female labor force (% of population) in Ukraine?
Your response must be concise. 14.6. In the year 2009, what is the difference between the Unemployed and educated female labor force (% of population) in Iceland and Unemployed and educated female labor force (% of population) in Panama?
Your answer should be compact. 32.7. In the year 2009, what is the difference between the Unemployed and educated female labor force (% of population) in Iceland and Unemployed and educated female labor force (% of population) in Ukraine?
Your answer should be very brief. 42.9. In the year 2009, what is the difference between the Unemployed and educated female labor force (% of population) of Panama and Unemployed and educated female labor force (% of population) of Ukraine?
Give a very brief answer. 10.2. In the year 2010, what is the difference between the Unemployed and educated female labor force (% of population) of Colombia and Unemployed and educated female labor force (% of population) of Iceland?
Your answer should be compact. -15.6. In the year 2010, what is the difference between the Unemployed and educated female labor force (% of population) in Colombia and Unemployed and educated female labor force (% of population) in Panama?
Offer a very short reply. 23.1. In the year 2010, what is the difference between the Unemployed and educated female labor force (% of population) in Colombia and Unemployed and educated female labor force (% of population) in Ukraine?
Your response must be concise. 32.4. In the year 2010, what is the difference between the Unemployed and educated female labor force (% of population) of Iceland and Unemployed and educated female labor force (% of population) of Panama?
Offer a very short reply. 38.7. In the year 2010, what is the difference between the Unemployed and educated female labor force (% of population) of Iceland and Unemployed and educated female labor force (% of population) of Ukraine?
Keep it short and to the point. 48. In the year 2011, what is the difference between the Unemployed and educated female labor force (% of population) of Colombia and Unemployed and educated female labor force (% of population) of Iceland?
Your answer should be compact. -30.2. In the year 2011, what is the difference between the Unemployed and educated female labor force (% of population) of Colombia and Unemployed and educated female labor force (% of population) of Panama?
Provide a short and direct response. 1.3. In the year 2011, what is the difference between the Unemployed and educated female labor force (% of population) in Iceland and Unemployed and educated female labor force (% of population) in Panama?
Provide a succinct answer. 31.5. In the year 2011, what is the difference between the Unemployed and educated female labor force (% of population) of Iceland and Unemployed and educated female labor force (% of population) of Ukraine?
Ensure brevity in your answer.  44.2. In the year 2011, what is the difference between the Unemployed and educated female labor force (% of population) in Panama and Unemployed and educated female labor force (% of population) in Ukraine?
Ensure brevity in your answer.  12.7. What is the ratio of the Unemployed and educated female labor force (% of population) of Colombia in 2004 to that in 2005?
Give a very brief answer. 1.11. What is the ratio of the Unemployed and educated female labor force (% of population) of Iceland in 2004 to that in 2005?
Provide a short and direct response. 0.96. What is the ratio of the Unemployed and educated female labor force (% of population) of Panama in 2004 to that in 2005?
Make the answer very short. 1.09. What is the ratio of the Unemployed and educated female labor force (% of population) of Ukraine in 2004 to that in 2005?
Keep it short and to the point. 1.42. What is the ratio of the Unemployed and educated female labor force (% of population) in Colombia in 2004 to that in 2006?
Keep it short and to the point. 1.06. What is the ratio of the Unemployed and educated female labor force (% of population) of Iceland in 2004 to that in 2006?
Make the answer very short. 1. What is the ratio of the Unemployed and educated female labor force (% of population) in Panama in 2004 to that in 2006?
Your answer should be very brief. 1.08. What is the ratio of the Unemployed and educated female labor force (% of population) in Ukraine in 2004 to that in 2006?
Provide a succinct answer. 1.66. What is the ratio of the Unemployed and educated female labor force (% of population) in Colombia in 2004 to that in 2007?
Your answer should be very brief. 1.09. What is the ratio of the Unemployed and educated female labor force (% of population) in Iceland in 2004 to that in 2007?
Make the answer very short. 0.82. What is the ratio of the Unemployed and educated female labor force (% of population) of Panama in 2004 to that in 2007?
Offer a terse response. 3.04. What is the ratio of the Unemployed and educated female labor force (% of population) of Ukraine in 2004 to that in 2007?
Provide a succinct answer. 2.07. What is the ratio of the Unemployed and educated female labor force (% of population) of Colombia in 2004 to that in 2008?
Ensure brevity in your answer.  0.59. What is the ratio of the Unemployed and educated female labor force (% of population) of Iceland in 2004 to that in 2008?
Your response must be concise. 0.75. What is the ratio of the Unemployed and educated female labor force (% of population) of Panama in 2004 to that in 2008?
Your answer should be very brief. 2.74. What is the ratio of the Unemployed and educated female labor force (% of population) of Colombia in 2004 to that in 2009?
Give a very brief answer. 1.01. What is the ratio of the Unemployed and educated female labor force (% of population) in Iceland in 2004 to that in 2009?
Provide a succinct answer. 0.91. What is the ratio of the Unemployed and educated female labor force (% of population) in Panama in 2004 to that in 2009?
Offer a very short reply. 1.54. What is the ratio of the Unemployed and educated female labor force (% of population) in Ukraine in 2004 to that in 2009?
Your answer should be compact. 1.82. What is the ratio of the Unemployed and educated female labor force (% of population) of Colombia in 2004 to that in 2010?
Provide a succinct answer. 0.57. What is the ratio of the Unemployed and educated female labor force (% of population) of Iceland in 2004 to that in 2010?
Provide a short and direct response. 0.85. What is the ratio of the Unemployed and educated female labor force (% of population) of Panama in 2004 to that in 2010?
Provide a succinct answer. 1.77. What is the ratio of the Unemployed and educated female labor force (% of population) in Ukraine in 2004 to that in 2010?
Keep it short and to the point. 2.23. What is the ratio of the Unemployed and educated female labor force (% of population) of Colombia in 2004 to that in 2011?
Your response must be concise. 1.17. What is the ratio of the Unemployed and educated female labor force (% of population) of Iceland in 2004 to that in 2011?
Keep it short and to the point. 0.93. What is the ratio of the Unemployed and educated female labor force (% of population) of Panama in 2004 to that in 2011?
Make the answer very short. 1.52. What is the ratio of the Unemployed and educated female labor force (% of population) of Ukraine in 2004 to that in 2011?
Keep it short and to the point. 2.74. What is the ratio of the Unemployed and educated female labor force (% of population) of Colombia in 2005 to that in 2006?
Give a very brief answer. 0.96. What is the ratio of the Unemployed and educated female labor force (% of population) in Iceland in 2005 to that in 2006?
Offer a very short reply. 1.03. What is the ratio of the Unemployed and educated female labor force (% of population) of Ukraine in 2005 to that in 2006?
Offer a terse response. 1.17. What is the ratio of the Unemployed and educated female labor force (% of population) of Colombia in 2005 to that in 2007?
Keep it short and to the point. 0.98. What is the ratio of the Unemployed and educated female labor force (% of population) in Iceland in 2005 to that in 2007?
Make the answer very short. 0.85. What is the ratio of the Unemployed and educated female labor force (% of population) in Panama in 2005 to that in 2007?
Your response must be concise. 2.78. What is the ratio of the Unemployed and educated female labor force (% of population) in Ukraine in 2005 to that in 2007?
Your response must be concise. 1.46. What is the ratio of the Unemployed and educated female labor force (% of population) in Colombia in 2005 to that in 2008?
Keep it short and to the point. 0.53. What is the ratio of the Unemployed and educated female labor force (% of population) of Iceland in 2005 to that in 2008?
Provide a succinct answer. 0.78. What is the ratio of the Unemployed and educated female labor force (% of population) in Panama in 2005 to that in 2008?
Your response must be concise. 2.51. What is the ratio of the Unemployed and educated female labor force (% of population) in Ukraine in 2005 to that in 2008?
Give a very brief answer. 1.41. What is the ratio of the Unemployed and educated female labor force (% of population) in Colombia in 2005 to that in 2009?
Make the answer very short. 0.91. What is the ratio of the Unemployed and educated female labor force (% of population) of Iceland in 2005 to that in 2009?
Your answer should be very brief. 0.95. What is the ratio of the Unemployed and educated female labor force (% of population) of Panama in 2005 to that in 2009?
Your answer should be compact. 1.41. What is the ratio of the Unemployed and educated female labor force (% of population) of Ukraine in 2005 to that in 2009?
Provide a short and direct response. 1.28. What is the ratio of the Unemployed and educated female labor force (% of population) in Colombia in 2005 to that in 2010?
Your response must be concise. 0.51. What is the ratio of the Unemployed and educated female labor force (% of population) of Iceland in 2005 to that in 2010?
Offer a very short reply. 0.88. What is the ratio of the Unemployed and educated female labor force (% of population) in Panama in 2005 to that in 2010?
Your response must be concise. 1.62. What is the ratio of the Unemployed and educated female labor force (% of population) of Ukraine in 2005 to that in 2010?
Ensure brevity in your answer.  1.57. What is the ratio of the Unemployed and educated female labor force (% of population) in Colombia in 2005 to that in 2011?
Keep it short and to the point. 1.05. What is the ratio of the Unemployed and educated female labor force (% of population) in Iceland in 2005 to that in 2011?
Offer a terse response. 0.96. What is the ratio of the Unemployed and educated female labor force (% of population) of Panama in 2005 to that in 2011?
Ensure brevity in your answer.  1.39. What is the ratio of the Unemployed and educated female labor force (% of population) of Ukraine in 2005 to that in 2011?
Ensure brevity in your answer.  1.93. What is the ratio of the Unemployed and educated female labor force (% of population) of Colombia in 2006 to that in 2007?
Your answer should be very brief. 1.03. What is the ratio of the Unemployed and educated female labor force (% of population) of Iceland in 2006 to that in 2007?
Provide a short and direct response. 0.83. What is the ratio of the Unemployed and educated female labor force (% of population) in Panama in 2006 to that in 2007?
Provide a succinct answer. 2.8. What is the ratio of the Unemployed and educated female labor force (% of population) of Ukraine in 2006 to that in 2007?
Your response must be concise. 1.25. What is the ratio of the Unemployed and educated female labor force (% of population) in Colombia in 2006 to that in 2008?
Provide a succinct answer. 0.55. What is the ratio of the Unemployed and educated female labor force (% of population) of Iceland in 2006 to that in 2008?
Keep it short and to the point. 0.75. What is the ratio of the Unemployed and educated female labor force (% of population) of Panama in 2006 to that in 2008?
Give a very brief answer. 2.53. What is the ratio of the Unemployed and educated female labor force (% of population) in Ukraine in 2006 to that in 2008?
Ensure brevity in your answer.  1.2. What is the ratio of the Unemployed and educated female labor force (% of population) of Colombia in 2006 to that in 2009?
Make the answer very short. 0.96. What is the ratio of the Unemployed and educated female labor force (% of population) of Iceland in 2006 to that in 2009?
Your answer should be very brief. 0.92. What is the ratio of the Unemployed and educated female labor force (% of population) in Panama in 2006 to that in 2009?
Your answer should be very brief. 1.43. What is the ratio of the Unemployed and educated female labor force (% of population) in Ukraine in 2006 to that in 2009?
Your answer should be compact. 1.09. What is the ratio of the Unemployed and educated female labor force (% of population) in Colombia in 2006 to that in 2010?
Your answer should be very brief. 0.54. What is the ratio of the Unemployed and educated female labor force (% of population) of Iceland in 2006 to that in 2010?
Keep it short and to the point. 0.85. What is the ratio of the Unemployed and educated female labor force (% of population) of Panama in 2006 to that in 2010?
Your answer should be very brief. 1.63. What is the ratio of the Unemployed and educated female labor force (% of population) of Ukraine in 2006 to that in 2010?
Provide a succinct answer. 1.34. What is the ratio of the Unemployed and educated female labor force (% of population) in Colombia in 2006 to that in 2011?
Your answer should be very brief. 1.1. What is the ratio of the Unemployed and educated female labor force (% of population) in Iceland in 2006 to that in 2011?
Offer a terse response. 0.93. What is the ratio of the Unemployed and educated female labor force (% of population) in Ukraine in 2006 to that in 2011?
Provide a short and direct response. 1.65. What is the ratio of the Unemployed and educated female labor force (% of population) of Colombia in 2007 to that in 2008?
Your answer should be very brief. 0.54. What is the ratio of the Unemployed and educated female labor force (% of population) of Iceland in 2007 to that in 2008?
Give a very brief answer. 0.91. What is the ratio of the Unemployed and educated female labor force (% of population) of Panama in 2007 to that in 2008?
Ensure brevity in your answer.  0.9. What is the ratio of the Unemployed and educated female labor force (% of population) in Ukraine in 2007 to that in 2008?
Your response must be concise. 0.97. What is the ratio of the Unemployed and educated female labor force (% of population) of Colombia in 2007 to that in 2009?
Provide a short and direct response. 0.93. What is the ratio of the Unemployed and educated female labor force (% of population) in Iceland in 2007 to that in 2009?
Offer a terse response. 1.11. What is the ratio of the Unemployed and educated female labor force (% of population) of Panama in 2007 to that in 2009?
Your response must be concise. 0.51. What is the ratio of the Unemployed and educated female labor force (% of population) in Ukraine in 2007 to that in 2009?
Offer a terse response. 0.88. What is the ratio of the Unemployed and educated female labor force (% of population) in Colombia in 2007 to that in 2010?
Make the answer very short. 0.52. What is the ratio of the Unemployed and educated female labor force (% of population) in Panama in 2007 to that in 2010?
Ensure brevity in your answer.  0.58. What is the ratio of the Unemployed and educated female labor force (% of population) in Ukraine in 2007 to that in 2010?
Keep it short and to the point. 1.08. What is the ratio of the Unemployed and educated female labor force (% of population) in Colombia in 2007 to that in 2011?
Keep it short and to the point. 1.07. What is the ratio of the Unemployed and educated female labor force (% of population) in Iceland in 2007 to that in 2011?
Offer a very short reply. 1.13. What is the ratio of the Unemployed and educated female labor force (% of population) of Panama in 2007 to that in 2011?
Your answer should be compact. 0.5. What is the ratio of the Unemployed and educated female labor force (% of population) in Ukraine in 2007 to that in 2011?
Your response must be concise. 1.33. What is the ratio of the Unemployed and educated female labor force (% of population) in Colombia in 2008 to that in 2009?
Ensure brevity in your answer.  1.73. What is the ratio of the Unemployed and educated female labor force (% of population) in Iceland in 2008 to that in 2009?
Give a very brief answer. 1.22. What is the ratio of the Unemployed and educated female labor force (% of population) of Panama in 2008 to that in 2009?
Your response must be concise. 0.56. What is the ratio of the Unemployed and educated female labor force (% of population) in Ukraine in 2008 to that in 2009?
Your response must be concise. 0.91. What is the ratio of the Unemployed and educated female labor force (% of population) in Colombia in 2008 to that in 2010?
Provide a succinct answer. 0.97. What is the ratio of the Unemployed and educated female labor force (% of population) of Iceland in 2008 to that in 2010?
Give a very brief answer. 1.13. What is the ratio of the Unemployed and educated female labor force (% of population) in Panama in 2008 to that in 2010?
Keep it short and to the point. 0.64. What is the ratio of the Unemployed and educated female labor force (% of population) of Ukraine in 2008 to that in 2010?
Keep it short and to the point. 1.11. What is the ratio of the Unemployed and educated female labor force (% of population) in Colombia in 2008 to that in 2011?
Your response must be concise. 1.99. What is the ratio of the Unemployed and educated female labor force (% of population) of Iceland in 2008 to that in 2011?
Make the answer very short. 1.24. What is the ratio of the Unemployed and educated female labor force (% of population) in Panama in 2008 to that in 2011?
Your answer should be compact. 0.55. What is the ratio of the Unemployed and educated female labor force (% of population) of Ukraine in 2008 to that in 2011?
Provide a short and direct response. 1.37. What is the ratio of the Unemployed and educated female labor force (% of population) of Colombia in 2009 to that in 2010?
Offer a very short reply. 0.56. What is the ratio of the Unemployed and educated female labor force (% of population) of Iceland in 2009 to that in 2010?
Keep it short and to the point. 0.93. What is the ratio of the Unemployed and educated female labor force (% of population) in Panama in 2009 to that in 2010?
Provide a short and direct response. 1.14. What is the ratio of the Unemployed and educated female labor force (% of population) of Ukraine in 2009 to that in 2010?
Offer a very short reply. 1.23. What is the ratio of the Unemployed and educated female labor force (% of population) in Colombia in 2009 to that in 2011?
Make the answer very short. 1.15. What is the ratio of the Unemployed and educated female labor force (% of population) of Iceland in 2009 to that in 2011?
Keep it short and to the point. 1.02. What is the ratio of the Unemployed and educated female labor force (% of population) of Panama in 2009 to that in 2011?
Provide a short and direct response. 0.98. What is the ratio of the Unemployed and educated female labor force (% of population) in Ukraine in 2009 to that in 2011?
Your answer should be compact. 1.51. What is the ratio of the Unemployed and educated female labor force (% of population) of Colombia in 2010 to that in 2011?
Make the answer very short. 2.06. What is the ratio of the Unemployed and educated female labor force (% of population) of Iceland in 2010 to that in 2011?
Offer a very short reply. 1.1. What is the ratio of the Unemployed and educated female labor force (% of population) of Panama in 2010 to that in 2011?
Provide a short and direct response. 0.86. What is the ratio of the Unemployed and educated female labor force (% of population) in Ukraine in 2010 to that in 2011?
Give a very brief answer. 1.23. What is the difference between the highest and the second highest Unemployed and educated female labor force (% of population) in Panama?
Give a very brief answer. 2. What is the difference between the highest and the second highest Unemployed and educated female labor force (% of population) of Ukraine?
Offer a terse response. 3.5. What is the difference between the highest and the lowest Unemployed and educated female labor force (% of population) in Colombia?
Offer a very short reply. 19.4. What is the difference between the highest and the lowest Unemployed and educated female labor force (% of population) of Iceland?
Ensure brevity in your answer.  15. What is the difference between the highest and the lowest Unemployed and educated female labor force (% of population) in Panama?
Your answer should be very brief. 17.3. 